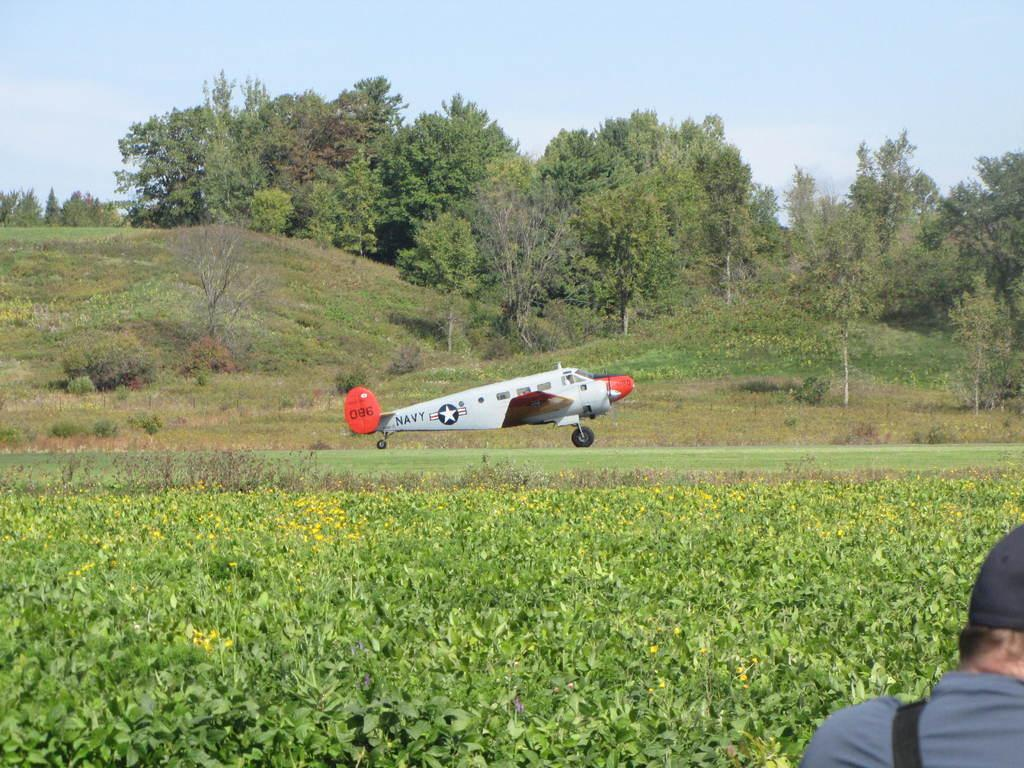What is the main subject in the image? There is a flying jet in the image. Can you describe the person in the image? There is a person wearing clothes and a cap in the image. What type of terrain is visible in the image? There is grass, hills, and trees visible in the image. What part of the natural environment is visible in the image? The sky is visible in the image. What number is written on the person's stomach in the image? There is no number written on the person's stomach in the image, as the person is wearing clothes and a cap. 